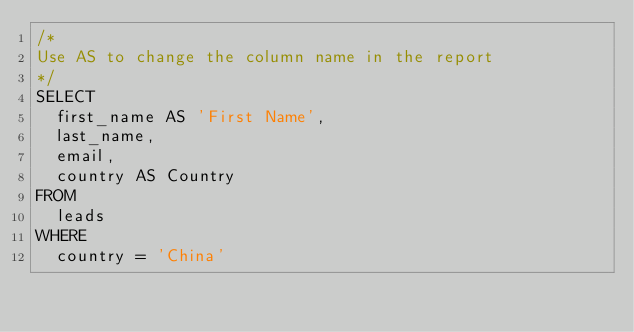Convert code to text. <code><loc_0><loc_0><loc_500><loc_500><_SQL_>/* 
Use AS to change the column name in the report
*/
SELECT 
  first_name AS 'First Name', 
  last_name, 
  email, 
  country AS Country 
FROM 
  leads 
WHERE 
  country = 'China'</code> 